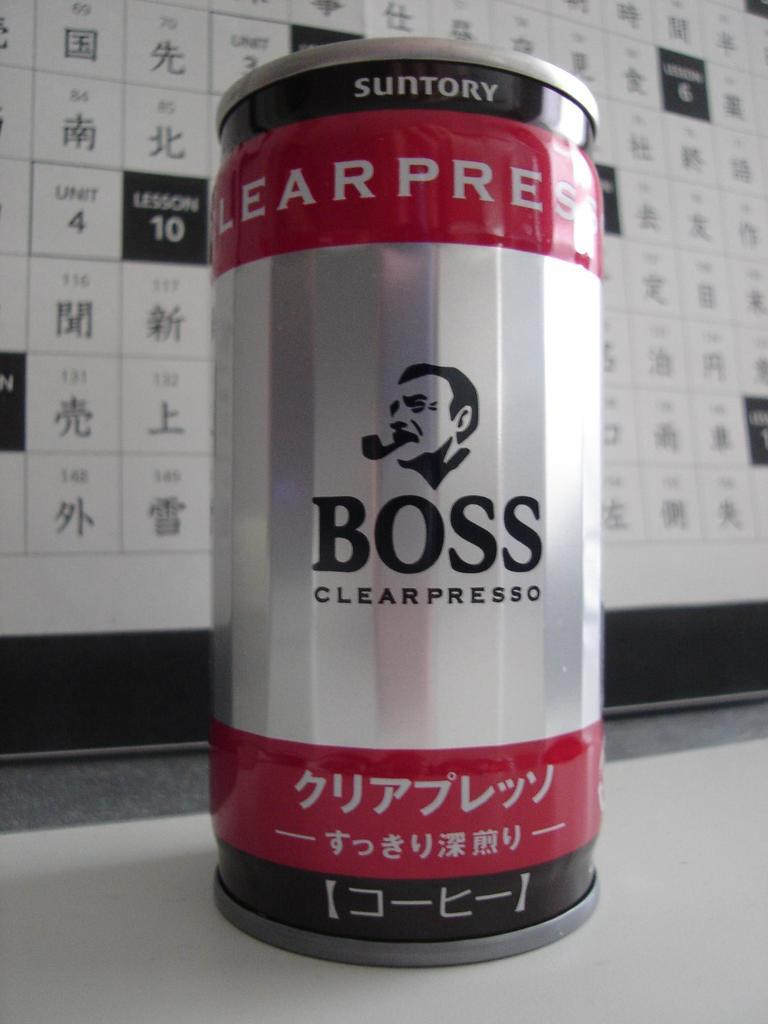<image>
Summarize the visual content of the image. japanese boss branded espresso in a red, silver and black can. 